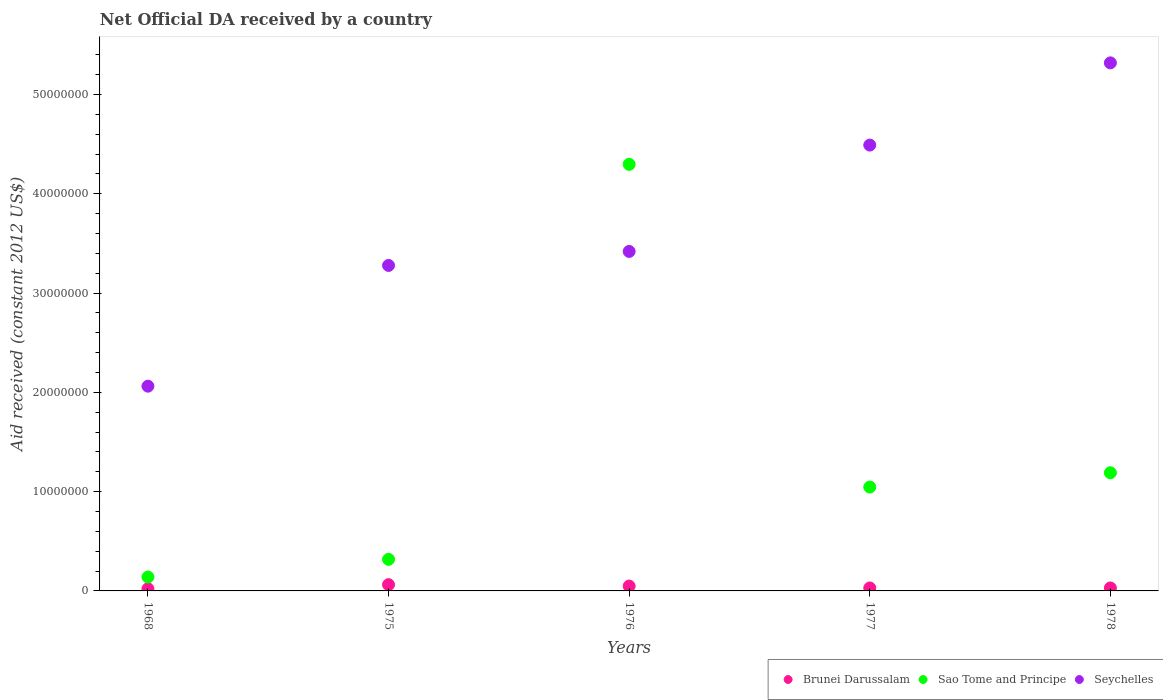What is the net official development assistance aid received in Brunei Darussalam in 1978?
Keep it short and to the point. 3.00e+05. Across all years, what is the maximum net official development assistance aid received in Seychelles?
Your answer should be compact. 5.32e+07. Across all years, what is the minimum net official development assistance aid received in Sao Tome and Principe?
Give a very brief answer. 1.40e+06. In which year was the net official development assistance aid received in Brunei Darussalam maximum?
Provide a short and direct response. 1975. In which year was the net official development assistance aid received in Sao Tome and Principe minimum?
Provide a short and direct response. 1968. What is the total net official development assistance aid received in Brunei Darussalam in the graph?
Keep it short and to the point. 1.94e+06. What is the difference between the net official development assistance aid received in Seychelles in 1968 and that in 1977?
Offer a very short reply. -2.43e+07. What is the difference between the net official development assistance aid received in Brunei Darussalam in 1976 and the net official development assistance aid received in Sao Tome and Principe in 1968?
Offer a very short reply. -9.10e+05. What is the average net official development assistance aid received in Sao Tome and Principe per year?
Your response must be concise. 1.40e+07. In the year 1975, what is the difference between the net official development assistance aid received in Seychelles and net official development assistance aid received in Brunei Darussalam?
Your response must be concise. 3.22e+07. What is the ratio of the net official development assistance aid received in Brunei Darussalam in 1968 to that in 1977?
Ensure brevity in your answer.  0.73. Is the difference between the net official development assistance aid received in Seychelles in 1975 and 1977 greater than the difference between the net official development assistance aid received in Brunei Darussalam in 1975 and 1977?
Give a very brief answer. No. What is the difference between the highest and the second highest net official development assistance aid received in Sao Tome and Principe?
Keep it short and to the point. 3.11e+07. What is the difference between the highest and the lowest net official development assistance aid received in Sao Tome and Principe?
Keep it short and to the point. 4.16e+07. In how many years, is the net official development assistance aid received in Sao Tome and Principe greater than the average net official development assistance aid received in Sao Tome and Principe taken over all years?
Your response must be concise. 1. Is it the case that in every year, the sum of the net official development assistance aid received in Sao Tome and Principe and net official development assistance aid received in Seychelles  is greater than the net official development assistance aid received in Brunei Darussalam?
Make the answer very short. Yes. Does the net official development assistance aid received in Seychelles monotonically increase over the years?
Make the answer very short. Yes. Is the net official development assistance aid received in Seychelles strictly greater than the net official development assistance aid received in Sao Tome and Principe over the years?
Make the answer very short. No. How many dotlines are there?
Ensure brevity in your answer.  3. How many legend labels are there?
Provide a succinct answer. 3. How are the legend labels stacked?
Offer a very short reply. Horizontal. What is the title of the graph?
Keep it short and to the point. Net Official DA received by a country. Does "Latvia" appear as one of the legend labels in the graph?
Your answer should be very brief. No. What is the label or title of the X-axis?
Provide a short and direct response. Years. What is the label or title of the Y-axis?
Your answer should be compact. Aid received (constant 2012 US$). What is the Aid received (constant 2012 US$) in Sao Tome and Principe in 1968?
Your answer should be very brief. 1.40e+06. What is the Aid received (constant 2012 US$) in Seychelles in 1968?
Provide a succinct answer. 2.06e+07. What is the Aid received (constant 2012 US$) of Brunei Darussalam in 1975?
Offer a terse response. 6.30e+05. What is the Aid received (constant 2012 US$) of Sao Tome and Principe in 1975?
Provide a short and direct response. 3.18e+06. What is the Aid received (constant 2012 US$) of Seychelles in 1975?
Offer a terse response. 3.28e+07. What is the Aid received (constant 2012 US$) in Sao Tome and Principe in 1976?
Offer a terse response. 4.30e+07. What is the Aid received (constant 2012 US$) of Seychelles in 1976?
Provide a succinct answer. 3.42e+07. What is the Aid received (constant 2012 US$) in Brunei Darussalam in 1977?
Your answer should be very brief. 3.00e+05. What is the Aid received (constant 2012 US$) of Sao Tome and Principe in 1977?
Give a very brief answer. 1.05e+07. What is the Aid received (constant 2012 US$) in Seychelles in 1977?
Keep it short and to the point. 4.49e+07. What is the Aid received (constant 2012 US$) in Sao Tome and Principe in 1978?
Give a very brief answer. 1.19e+07. What is the Aid received (constant 2012 US$) of Seychelles in 1978?
Your answer should be compact. 5.32e+07. Across all years, what is the maximum Aid received (constant 2012 US$) in Brunei Darussalam?
Give a very brief answer. 6.30e+05. Across all years, what is the maximum Aid received (constant 2012 US$) of Sao Tome and Principe?
Your response must be concise. 4.30e+07. Across all years, what is the maximum Aid received (constant 2012 US$) of Seychelles?
Offer a terse response. 5.32e+07. Across all years, what is the minimum Aid received (constant 2012 US$) in Sao Tome and Principe?
Make the answer very short. 1.40e+06. Across all years, what is the minimum Aid received (constant 2012 US$) of Seychelles?
Keep it short and to the point. 2.06e+07. What is the total Aid received (constant 2012 US$) of Brunei Darussalam in the graph?
Offer a very short reply. 1.94e+06. What is the total Aid received (constant 2012 US$) of Sao Tome and Principe in the graph?
Provide a succinct answer. 6.99e+07. What is the total Aid received (constant 2012 US$) of Seychelles in the graph?
Ensure brevity in your answer.  1.86e+08. What is the difference between the Aid received (constant 2012 US$) of Brunei Darussalam in 1968 and that in 1975?
Give a very brief answer. -4.10e+05. What is the difference between the Aid received (constant 2012 US$) of Sao Tome and Principe in 1968 and that in 1975?
Ensure brevity in your answer.  -1.78e+06. What is the difference between the Aid received (constant 2012 US$) in Seychelles in 1968 and that in 1975?
Your answer should be compact. -1.22e+07. What is the difference between the Aid received (constant 2012 US$) of Brunei Darussalam in 1968 and that in 1976?
Make the answer very short. -2.70e+05. What is the difference between the Aid received (constant 2012 US$) of Sao Tome and Principe in 1968 and that in 1976?
Keep it short and to the point. -4.16e+07. What is the difference between the Aid received (constant 2012 US$) in Seychelles in 1968 and that in 1976?
Keep it short and to the point. -1.36e+07. What is the difference between the Aid received (constant 2012 US$) in Brunei Darussalam in 1968 and that in 1977?
Provide a succinct answer. -8.00e+04. What is the difference between the Aid received (constant 2012 US$) of Sao Tome and Principe in 1968 and that in 1977?
Ensure brevity in your answer.  -9.06e+06. What is the difference between the Aid received (constant 2012 US$) of Seychelles in 1968 and that in 1977?
Offer a very short reply. -2.43e+07. What is the difference between the Aid received (constant 2012 US$) of Sao Tome and Principe in 1968 and that in 1978?
Your answer should be very brief. -1.05e+07. What is the difference between the Aid received (constant 2012 US$) in Seychelles in 1968 and that in 1978?
Keep it short and to the point. -3.26e+07. What is the difference between the Aid received (constant 2012 US$) of Brunei Darussalam in 1975 and that in 1976?
Provide a succinct answer. 1.40e+05. What is the difference between the Aid received (constant 2012 US$) in Sao Tome and Principe in 1975 and that in 1976?
Provide a short and direct response. -3.98e+07. What is the difference between the Aid received (constant 2012 US$) of Seychelles in 1975 and that in 1976?
Provide a succinct answer. -1.41e+06. What is the difference between the Aid received (constant 2012 US$) in Sao Tome and Principe in 1975 and that in 1977?
Keep it short and to the point. -7.28e+06. What is the difference between the Aid received (constant 2012 US$) of Seychelles in 1975 and that in 1977?
Give a very brief answer. -1.21e+07. What is the difference between the Aid received (constant 2012 US$) of Brunei Darussalam in 1975 and that in 1978?
Your answer should be compact. 3.30e+05. What is the difference between the Aid received (constant 2012 US$) in Sao Tome and Principe in 1975 and that in 1978?
Make the answer very short. -8.72e+06. What is the difference between the Aid received (constant 2012 US$) of Seychelles in 1975 and that in 1978?
Provide a succinct answer. -2.04e+07. What is the difference between the Aid received (constant 2012 US$) of Brunei Darussalam in 1976 and that in 1977?
Offer a very short reply. 1.90e+05. What is the difference between the Aid received (constant 2012 US$) in Sao Tome and Principe in 1976 and that in 1977?
Offer a very short reply. 3.25e+07. What is the difference between the Aid received (constant 2012 US$) of Seychelles in 1976 and that in 1977?
Your answer should be compact. -1.07e+07. What is the difference between the Aid received (constant 2012 US$) of Sao Tome and Principe in 1976 and that in 1978?
Ensure brevity in your answer.  3.11e+07. What is the difference between the Aid received (constant 2012 US$) in Seychelles in 1976 and that in 1978?
Ensure brevity in your answer.  -1.90e+07. What is the difference between the Aid received (constant 2012 US$) in Brunei Darussalam in 1977 and that in 1978?
Keep it short and to the point. 0. What is the difference between the Aid received (constant 2012 US$) in Sao Tome and Principe in 1977 and that in 1978?
Your answer should be compact. -1.44e+06. What is the difference between the Aid received (constant 2012 US$) in Seychelles in 1977 and that in 1978?
Make the answer very short. -8.28e+06. What is the difference between the Aid received (constant 2012 US$) of Brunei Darussalam in 1968 and the Aid received (constant 2012 US$) of Sao Tome and Principe in 1975?
Provide a short and direct response. -2.96e+06. What is the difference between the Aid received (constant 2012 US$) of Brunei Darussalam in 1968 and the Aid received (constant 2012 US$) of Seychelles in 1975?
Keep it short and to the point. -3.26e+07. What is the difference between the Aid received (constant 2012 US$) in Sao Tome and Principe in 1968 and the Aid received (constant 2012 US$) in Seychelles in 1975?
Offer a terse response. -3.14e+07. What is the difference between the Aid received (constant 2012 US$) of Brunei Darussalam in 1968 and the Aid received (constant 2012 US$) of Sao Tome and Principe in 1976?
Keep it short and to the point. -4.27e+07. What is the difference between the Aid received (constant 2012 US$) in Brunei Darussalam in 1968 and the Aid received (constant 2012 US$) in Seychelles in 1976?
Provide a short and direct response. -3.40e+07. What is the difference between the Aid received (constant 2012 US$) in Sao Tome and Principe in 1968 and the Aid received (constant 2012 US$) in Seychelles in 1976?
Keep it short and to the point. -3.28e+07. What is the difference between the Aid received (constant 2012 US$) in Brunei Darussalam in 1968 and the Aid received (constant 2012 US$) in Sao Tome and Principe in 1977?
Offer a very short reply. -1.02e+07. What is the difference between the Aid received (constant 2012 US$) of Brunei Darussalam in 1968 and the Aid received (constant 2012 US$) of Seychelles in 1977?
Your answer should be very brief. -4.47e+07. What is the difference between the Aid received (constant 2012 US$) in Sao Tome and Principe in 1968 and the Aid received (constant 2012 US$) in Seychelles in 1977?
Your answer should be very brief. -4.35e+07. What is the difference between the Aid received (constant 2012 US$) in Brunei Darussalam in 1968 and the Aid received (constant 2012 US$) in Sao Tome and Principe in 1978?
Your answer should be very brief. -1.17e+07. What is the difference between the Aid received (constant 2012 US$) in Brunei Darussalam in 1968 and the Aid received (constant 2012 US$) in Seychelles in 1978?
Provide a short and direct response. -5.30e+07. What is the difference between the Aid received (constant 2012 US$) in Sao Tome and Principe in 1968 and the Aid received (constant 2012 US$) in Seychelles in 1978?
Your answer should be very brief. -5.18e+07. What is the difference between the Aid received (constant 2012 US$) of Brunei Darussalam in 1975 and the Aid received (constant 2012 US$) of Sao Tome and Principe in 1976?
Offer a very short reply. -4.23e+07. What is the difference between the Aid received (constant 2012 US$) in Brunei Darussalam in 1975 and the Aid received (constant 2012 US$) in Seychelles in 1976?
Offer a very short reply. -3.36e+07. What is the difference between the Aid received (constant 2012 US$) of Sao Tome and Principe in 1975 and the Aid received (constant 2012 US$) of Seychelles in 1976?
Give a very brief answer. -3.10e+07. What is the difference between the Aid received (constant 2012 US$) in Brunei Darussalam in 1975 and the Aid received (constant 2012 US$) in Sao Tome and Principe in 1977?
Make the answer very short. -9.83e+06. What is the difference between the Aid received (constant 2012 US$) of Brunei Darussalam in 1975 and the Aid received (constant 2012 US$) of Seychelles in 1977?
Offer a very short reply. -4.43e+07. What is the difference between the Aid received (constant 2012 US$) of Sao Tome and Principe in 1975 and the Aid received (constant 2012 US$) of Seychelles in 1977?
Your answer should be compact. -4.17e+07. What is the difference between the Aid received (constant 2012 US$) in Brunei Darussalam in 1975 and the Aid received (constant 2012 US$) in Sao Tome and Principe in 1978?
Keep it short and to the point. -1.13e+07. What is the difference between the Aid received (constant 2012 US$) of Brunei Darussalam in 1975 and the Aid received (constant 2012 US$) of Seychelles in 1978?
Give a very brief answer. -5.26e+07. What is the difference between the Aid received (constant 2012 US$) of Sao Tome and Principe in 1975 and the Aid received (constant 2012 US$) of Seychelles in 1978?
Give a very brief answer. -5.00e+07. What is the difference between the Aid received (constant 2012 US$) in Brunei Darussalam in 1976 and the Aid received (constant 2012 US$) in Sao Tome and Principe in 1977?
Provide a succinct answer. -9.97e+06. What is the difference between the Aid received (constant 2012 US$) in Brunei Darussalam in 1976 and the Aid received (constant 2012 US$) in Seychelles in 1977?
Offer a very short reply. -4.44e+07. What is the difference between the Aid received (constant 2012 US$) of Sao Tome and Principe in 1976 and the Aid received (constant 2012 US$) of Seychelles in 1977?
Make the answer very short. -1.94e+06. What is the difference between the Aid received (constant 2012 US$) in Brunei Darussalam in 1976 and the Aid received (constant 2012 US$) in Sao Tome and Principe in 1978?
Provide a succinct answer. -1.14e+07. What is the difference between the Aid received (constant 2012 US$) in Brunei Darussalam in 1976 and the Aid received (constant 2012 US$) in Seychelles in 1978?
Make the answer very short. -5.27e+07. What is the difference between the Aid received (constant 2012 US$) of Sao Tome and Principe in 1976 and the Aid received (constant 2012 US$) of Seychelles in 1978?
Keep it short and to the point. -1.02e+07. What is the difference between the Aid received (constant 2012 US$) in Brunei Darussalam in 1977 and the Aid received (constant 2012 US$) in Sao Tome and Principe in 1978?
Your answer should be very brief. -1.16e+07. What is the difference between the Aid received (constant 2012 US$) of Brunei Darussalam in 1977 and the Aid received (constant 2012 US$) of Seychelles in 1978?
Give a very brief answer. -5.29e+07. What is the difference between the Aid received (constant 2012 US$) of Sao Tome and Principe in 1977 and the Aid received (constant 2012 US$) of Seychelles in 1978?
Make the answer very short. -4.27e+07. What is the average Aid received (constant 2012 US$) in Brunei Darussalam per year?
Your response must be concise. 3.88e+05. What is the average Aid received (constant 2012 US$) of Sao Tome and Principe per year?
Your answer should be compact. 1.40e+07. What is the average Aid received (constant 2012 US$) of Seychelles per year?
Keep it short and to the point. 3.71e+07. In the year 1968, what is the difference between the Aid received (constant 2012 US$) of Brunei Darussalam and Aid received (constant 2012 US$) of Sao Tome and Principe?
Keep it short and to the point. -1.18e+06. In the year 1968, what is the difference between the Aid received (constant 2012 US$) of Brunei Darussalam and Aid received (constant 2012 US$) of Seychelles?
Keep it short and to the point. -2.04e+07. In the year 1968, what is the difference between the Aid received (constant 2012 US$) in Sao Tome and Principe and Aid received (constant 2012 US$) in Seychelles?
Provide a succinct answer. -1.92e+07. In the year 1975, what is the difference between the Aid received (constant 2012 US$) of Brunei Darussalam and Aid received (constant 2012 US$) of Sao Tome and Principe?
Make the answer very short. -2.55e+06. In the year 1975, what is the difference between the Aid received (constant 2012 US$) in Brunei Darussalam and Aid received (constant 2012 US$) in Seychelles?
Your answer should be compact. -3.22e+07. In the year 1975, what is the difference between the Aid received (constant 2012 US$) of Sao Tome and Principe and Aid received (constant 2012 US$) of Seychelles?
Your answer should be very brief. -2.96e+07. In the year 1976, what is the difference between the Aid received (constant 2012 US$) of Brunei Darussalam and Aid received (constant 2012 US$) of Sao Tome and Principe?
Your answer should be very brief. -4.25e+07. In the year 1976, what is the difference between the Aid received (constant 2012 US$) of Brunei Darussalam and Aid received (constant 2012 US$) of Seychelles?
Keep it short and to the point. -3.37e+07. In the year 1976, what is the difference between the Aid received (constant 2012 US$) in Sao Tome and Principe and Aid received (constant 2012 US$) in Seychelles?
Provide a short and direct response. 8.77e+06. In the year 1977, what is the difference between the Aid received (constant 2012 US$) of Brunei Darussalam and Aid received (constant 2012 US$) of Sao Tome and Principe?
Your response must be concise. -1.02e+07. In the year 1977, what is the difference between the Aid received (constant 2012 US$) of Brunei Darussalam and Aid received (constant 2012 US$) of Seychelles?
Provide a succinct answer. -4.46e+07. In the year 1977, what is the difference between the Aid received (constant 2012 US$) of Sao Tome and Principe and Aid received (constant 2012 US$) of Seychelles?
Provide a succinct answer. -3.44e+07. In the year 1978, what is the difference between the Aid received (constant 2012 US$) in Brunei Darussalam and Aid received (constant 2012 US$) in Sao Tome and Principe?
Keep it short and to the point. -1.16e+07. In the year 1978, what is the difference between the Aid received (constant 2012 US$) in Brunei Darussalam and Aid received (constant 2012 US$) in Seychelles?
Make the answer very short. -5.29e+07. In the year 1978, what is the difference between the Aid received (constant 2012 US$) of Sao Tome and Principe and Aid received (constant 2012 US$) of Seychelles?
Your answer should be very brief. -4.13e+07. What is the ratio of the Aid received (constant 2012 US$) of Brunei Darussalam in 1968 to that in 1975?
Your answer should be very brief. 0.35. What is the ratio of the Aid received (constant 2012 US$) in Sao Tome and Principe in 1968 to that in 1975?
Ensure brevity in your answer.  0.44. What is the ratio of the Aid received (constant 2012 US$) in Seychelles in 1968 to that in 1975?
Your answer should be very brief. 0.63. What is the ratio of the Aid received (constant 2012 US$) of Brunei Darussalam in 1968 to that in 1976?
Keep it short and to the point. 0.45. What is the ratio of the Aid received (constant 2012 US$) of Sao Tome and Principe in 1968 to that in 1976?
Provide a short and direct response. 0.03. What is the ratio of the Aid received (constant 2012 US$) of Seychelles in 1968 to that in 1976?
Provide a short and direct response. 0.6. What is the ratio of the Aid received (constant 2012 US$) in Brunei Darussalam in 1968 to that in 1977?
Give a very brief answer. 0.73. What is the ratio of the Aid received (constant 2012 US$) in Sao Tome and Principe in 1968 to that in 1977?
Keep it short and to the point. 0.13. What is the ratio of the Aid received (constant 2012 US$) of Seychelles in 1968 to that in 1977?
Provide a short and direct response. 0.46. What is the ratio of the Aid received (constant 2012 US$) of Brunei Darussalam in 1968 to that in 1978?
Give a very brief answer. 0.73. What is the ratio of the Aid received (constant 2012 US$) of Sao Tome and Principe in 1968 to that in 1978?
Ensure brevity in your answer.  0.12. What is the ratio of the Aid received (constant 2012 US$) of Seychelles in 1968 to that in 1978?
Keep it short and to the point. 0.39. What is the ratio of the Aid received (constant 2012 US$) in Sao Tome and Principe in 1975 to that in 1976?
Keep it short and to the point. 0.07. What is the ratio of the Aid received (constant 2012 US$) of Seychelles in 1975 to that in 1976?
Provide a succinct answer. 0.96. What is the ratio of the Aid received (constant 2012 US$) of Sao Tome and Principe in 1975 to that in 1977?
Offer a very short reply. 0.3. What is the ratio of the Aid received (constant 2012 US$) of Seychelles in 1975 to that in 1977?
Your answer should be compact. 0.73. What is the ratio of the Aid received (constant 2012 US$) in Sao Tome and Principe in 1975 to that in 1978?
Offer a terse response. 0.27. What is the ratio of the Aid received (constant 2012 US$) of Seychelles in 1975 to that in 1978?
Provide a short and direct response. 0.62. What is the ratio of the Aid received (constant 2012 US$) in Brunei Darussalam in 1976 to that in 1977?
Your response must be concise. 1.63. What is the ratio of the Aid received (constant 2012 US$) in Sao Tome and Principe in 1976 to that in 1977?
Give a very brief answer. 4.11. What is the ratio of the Aid received (constant 2012 US$) in Seychelles in 1976 to that in 1977?
Provide a succinct answer. 0.76. What is the ratio of the Aid received (constant 2012 US$) of Brunei Darussalam in 1976 to that in 1978?
Offer a very short reply. 1.63. What is the ratio of the Aid received (constant 2012 US$) of Sao Tome and Principe in 1976 to that in 1978?
Your answer should be very brief. 3.61. What is the ratio of the Aid received (constant 2012 US$) of Seychelles in 1976 to that in 1978?
Your answer should be compact. 0.64. What is the ratio of the Aid received (constant 2012 US$) of Brunei Darussalam in 1977 to that in 1978?
Keep it short and to the point. 1. What is the ratio of the Aid received (constant 2012 US$) of Sao Tome and Principe in 1977 to that in 1978?
Your answer should be compact. 0.88. What is the ratio of the Aid received (constant 2012 US$) in Seychelles in 1977 to that in 1978?
Provide a succinct answer. 0.84. What is the difference between the highest and the second highest Aid received (constant 2012 US$) in Sao Tome and Principe?
Offer a very short reply. 3.11e+07. What is the difference between the highest and the second highest Aid received (constant 2012 US$) of Seychelles?
Provide a short and direct response. 8.28e+06. What is the difference between the highest and the lowest Aid received (constant 2012 US$) in Brunei Darussalam?
Give a very brief answer. 4.10e+05. What is the difference between the highest and the lowest Aid received (constant 2012 US$) in Sao Tome and Principe?
Your answer should be compact. 4.16e+07. What is the difference between the highest and the lowest Aid received (constant 2012 US$) of Seychelles?
Offer a terse response. 3.26e+07. 